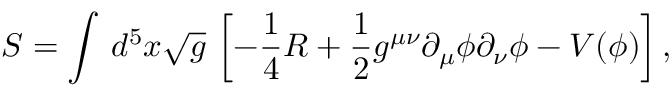<formula> <loc_0><loc_0><loc_500><loc_500>S = \int \, d ^ { 5 } x \sqrt { g } \, \left [ - \frac { 1 } { 4 } R + \frac { 1 } { 2 } g ^ { \mu \nu } \partial _ { \mu } \phi \partial _ { \nu } \phi - V ( \phi ) \right ] ,</formula> 